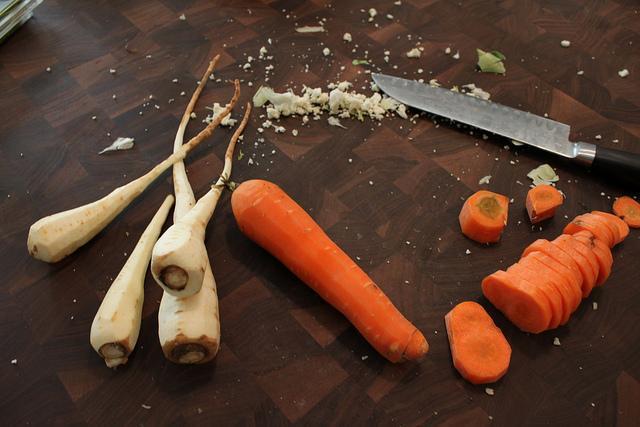How many carrots are visible?
Give a very brief answer. 5. 